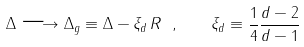<formula> <loc_0><loc_0><loc_500><loc_500>\Delta \longrightarrow \Delta _ { g } \equiv \Delta - \xi _ { d } \, R \ , \quad \xi _ { d } \equiv \frac { 1 } { 4 } \frac { d - 2 } { d - 1 }</formula> 